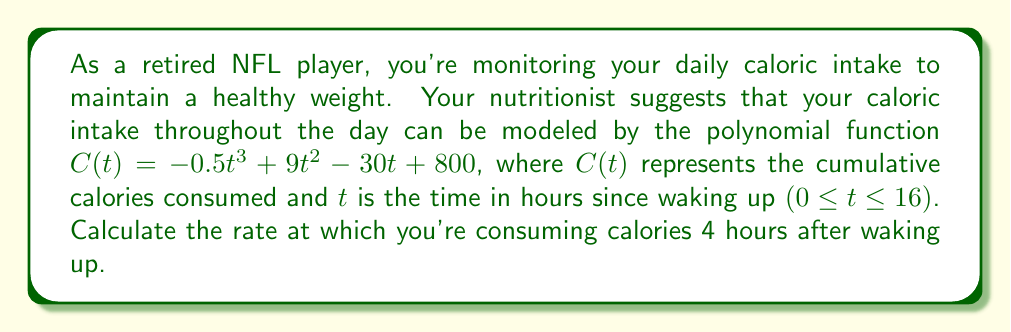Help me with this question. To find the rate of calorie consumption at a specific time, we need to find the derivative of the caloric intake function $C(t)$.

1. Given function: $C(t) = -0.5t^3 + 9t^2 - 30t + 800$

2. Calculate the derivative $C'(t)$:
   $C'(t) = \frac{d}{dt}(-0.5t^3 + 9t^2 - 30t + 800)$
   $C'(t) = -1.5t^2 + 18t - 30$

3. The derivative $C'(t)$ represents the rate of calorie consumption at any given time $t$.

4. We want to find the rate 4 hours after waking up, so substitute $t = 4$ into $C'(t)$:
   $C'(4) = -1.5(4)^2 + 18(4) - 30$
   $C'(4) = -1.5(16) + 72 - 30$
   $C'(4) = -24 + 72 - 30$
   $C'(4) = 18$

5. Therefore, the rate of calorie consumption 4 hours after waking up is 18 calories per hour.
Answer: 18 calories per hour 